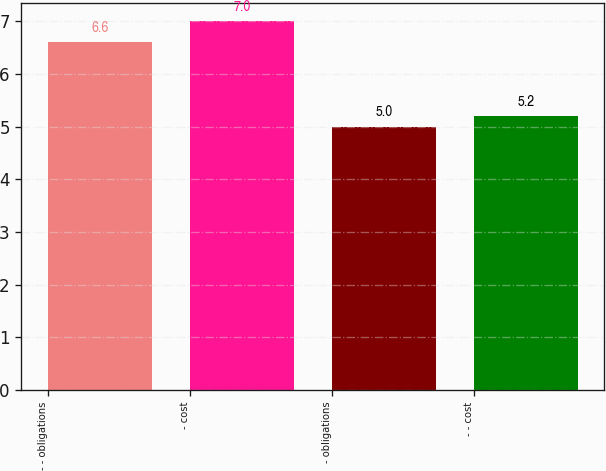<chart> <loc_0><loc_0><loc_500><loc_500><bar_chart><fcel>- - obligations<fcel>- cost<fcel>- obligations<fcel>- - cost<nl><fcel>6.6<fcel>7<fcel>5<fcel>5.2<nl></chart> 